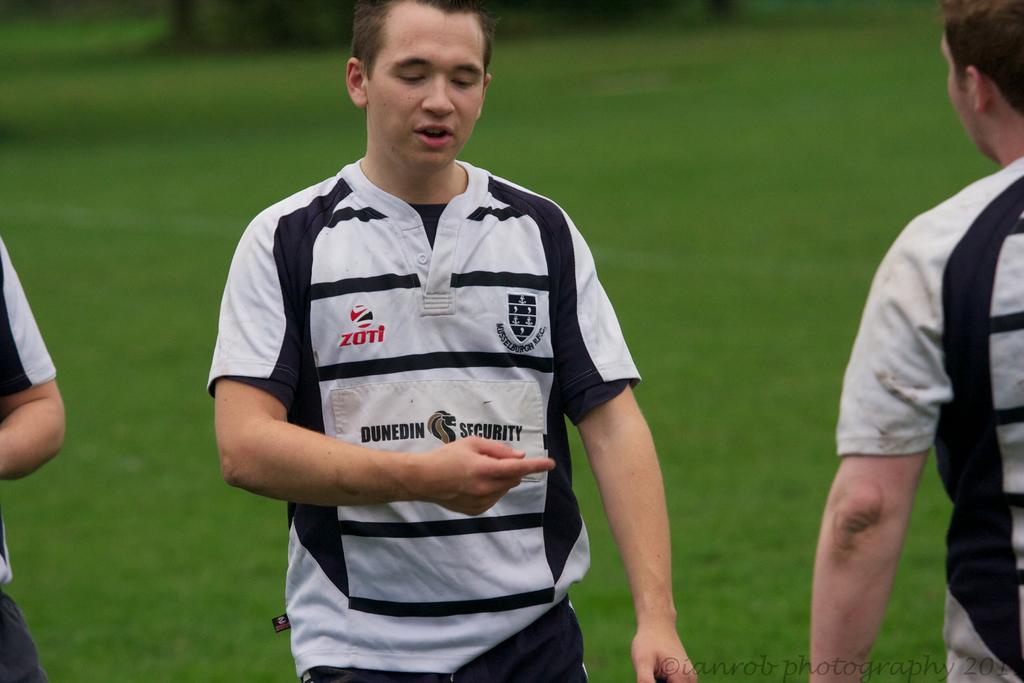Provide a one-sentence caption for the provided image. Wearing a Dunedin Security shirt, a boy points while talking to another boy. 